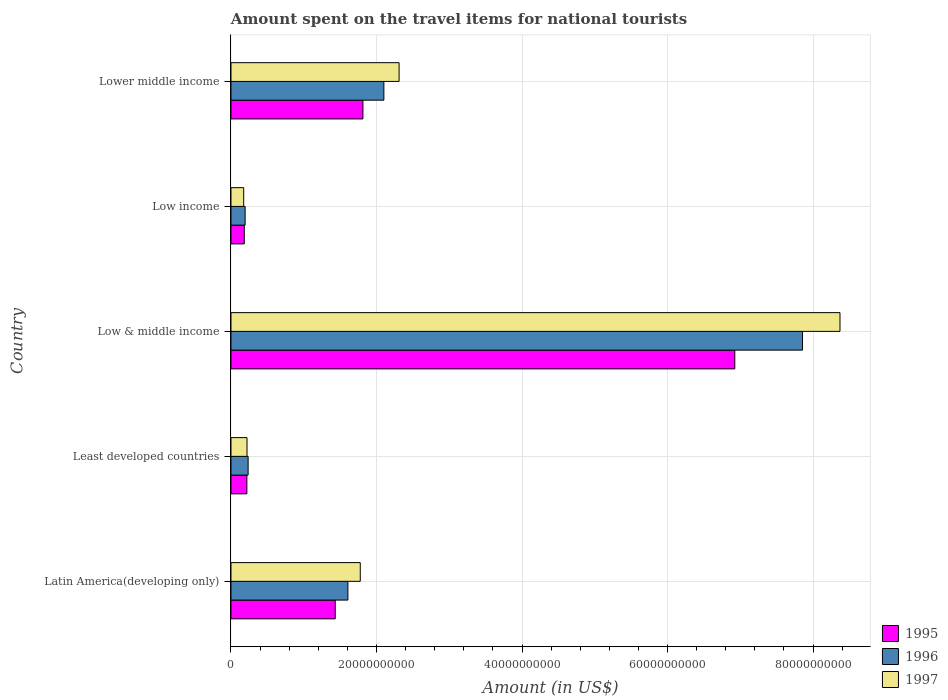How many groups of bars are there?
Your answer should be very brief. 5. Are the number of bars per tick equal to the number of legend labels?
Make the answer very short. Yes. How many bars are there on the 5th tick from the top?
Your response must be concise. 3. What is the amount spent on the travel items for national tourists in 1996 in Least developed countries?
Offer a very short reply. 2.36e+09. Across all countries, what is the maximum amount spent on the travel items for national tourists in 1996?
Your answer should be compact. 7.85e+1. Across all countries, what is the minimum amount spent on the travel items for national tourists in 1996?
Your answer should be very brief. 1.94e+09. In which country was the amount spent on the travel items for national tourists in 1997 maximum?
Your response must be concise. Low & middle income. In which country was the amount spent on the travel items for national tourists in 1995 minimum?
Make the answer very short. Low income. What is the total amount spent on the travel items for national tourists in 1995 in the graph?
Give a very brief answer. 1.06e+11. What is the difference between the amount spent on the travel items for national tourists in 1996 in Least developed countries and that in Low income?
Make the answer very short. 4.11e+08. What is the difference between the amount spent on the travel items for national tourists in 1995 in Lower middle income and the amount spent on the travel items for national tourists in 1996 in Low income?
Provide a succinct answer. 1.62e+1. What is the average amount spent on the travel items for national tourists in 1997 per country?
Provide a succinct answer. 2.57e+1. What is the difference between the amount spent on the travel items for national tourists in 1996 and amount spent on the travel items for national tourists in 1995 in Lower middle income?
Offer a terse response. 2.88e+09. In how many countries, is the amount spent on the travel items for national tourists in 1996 greater than 4000000000 US$?
Offer a very short reply. 3. What is the ratio of the amount spent on the travel items for national tourists in 1997 in Low income to that in Lower middle income?
Your response must be concise. 0.08. What is the difference between the highest and the second highest amount spent on the travel items for national tourists in 1997?
Give a very brief answer. 6.06e+1. What is the difference between the highest and the lowest amount spent on the travel items for national tourists in 1997?
Offer a very short reply. 8.19e+1. In how many countries, is the amount spent on the travel items for national tourists in 1997 greater than the average amount spent on the travel items for national tourists in 1997 taken over all countries?
Make the answer very short. 1. Is the sum of the amount spent on the travel items for national tourists in 1995 in Low income and Lower middle income greater than the maximum amount spent on the travel items for national tourists in 1996 across all countries?
Your answer should be very brief. No. Is it the case that in every country, the sum of the amount spent on the travel items for national tourists in 1997 and amount spent on the travel items for national tourists in 1995 is greater than the amount spent on the travel items for national tourists in 1996?
Offer a terse response. Yes. How many bars are there?
Your answer should be compact. 15. Are all the bars in the graph horizontal?
Provide a short and direct response. Yes. Are the values on the major ticks of X-axis written in scientific E-notation?
Offer a terse response. No. Does the graph contain any zero values?
Offer a very short reply. No. Where does the legend appear in the graph?
Your answer should be compact. Bottom right. How many legend labels are there?
Offer a very short reply. 3. What is the title of the graph?
Your answer should be very brief. Amount spent on the travel items for national tourists. What is the label or title of the X-axis?
Give a very brief answer. Amount (in US$). What is the label or title of the Y-axis?
Your answer should be very brief. Country. What is the Amount (in US$) of 1995 in Latin America(developing only)?
Your response must be concise. 1.43e+1. What is the Amount (in US$) of 1996 in Latin America(developing only)?
Give a very brief answer. 1.61e+1. What is the Amount (in US$) in 1997 in Latin America(developing only)?
Your answer should be very brief. 1.78e+1. What is the Amount (in US$) in 1995 in Least developed countries?
Offer a very short reply. 2.19e+09. What is the Amount (in US$) of 1996 in Least developed countries?
Keep it short and to the point. 2.36e+09. What is the Amount (in US$) in 1997 in Least developed countries?
Provide a succinct answer. 2.20e+09. What is the Amount (in US$) in 1995 in Low & middle income?
Your answer should be compact. 6.92e+1. What is the Amount (in US$) in 1996 in Low & middle income?
Offer a very short reply. 7.85e+1. What is the Amount (in US$) of 1997 in Low & middle income?
Offer a terse response. 8.37e+1. What is the Amount (in US$) of 1995 in Low income?
Offer a terse response. 1.83e+09. What is the Amount (in US$) in 1996 in Low income?
Your response must be concise. 1.94e+09. What is the Amount (in US$) of 1997 in Low income?
Provide a short and direct response. 1.75e+09. What is the Amount (in US$) in 1995 in Lower middle income?
Keep it short and to the point. 1.81e+1. What is the Amount (in US$) in 1996 in Lower middle income?
Provide a succinct answer. 2.10e+1. What is the Amount (in US$) of 1997 in Lower middle income?
Offer a terse response. 2.31e+1. Across all countries, what is the maximum Amount (in US$) of 1995?
Offer a terse response. 6.92e+1. Across all countries, what is the maximum Amount (in US$) of 1996?
Provide a succinct answer. 7.85e+1. Across all countries, what is the maximum Amount (in US$) in 1997?
Provide a succinct answer. 8.37e+1. Across all countries, what is the minimum Amount (in US$) of 1995?
Provide a short and direct response. 1.83e+09. Across all countries, what is the minimum Amount (in US$) of 1996?
Provide a succinct answer. 1.94e+09. Across all countries, what is the minimum Amount (in US$) of 1997?
Provide a succinct answer. 1.75e+09. What is the total Amount (in US$) in 1995 in the graph?
Your answer should be compact. 1.06e+11. What is the total Amount (in US$) of 1996 in the graph?
Offer a terse response. 1.20e+11. What is the total Amount (in US$) in 1997 in the graph?
Provide a short and direct response. 1.29e+11. What is the difference between the Amount (in US$) of 1995 in Latin America(developing only) and that in Least developed countries?
Give a very brief answer. 1.21e+1. What is the difference between the Amount (in US$) in 1996 in Latin America(developing only) and that in Least developed countries?
Offer a terse response. 1.37e+1. What is the difference between the Amount (in US$) of 1997 in Latin America(developing only) and that in Least developed countries?
Your response must be concise. 1.56e+1. What is the difference between the Amount (in US$) of 1995 in Latin America(developing only) and that in Low & middle income?
Your response must be concise. -5.49e+1. What is the difference between the Amount (in US$) of 1996 in Latin America(developing only) and that in Low & middle income?
Provide a succinct answer. -6.25e+1. What is the difference between the Amount (in US$) in 1997 in Latin America(developing only) and that in Low & middle income?
Provide a succinct answer. -6.59e+1. What is the difference between the Amount (in US$) in 1995 in Latin America(developing only) and that in Low income?
Provide a short and direct response. 1.25e+1. What is the difference between the Amount (in US$) of 1996 in Latin America(developing only) and that in Low income?
Provide a short and direct response. 1.41e+1. What is the difference between the Amount (in US$) of 1997 in Latin America(developing only) and that in Low income?
Provide a short and direct response. 1.60e+1. What is the difference between the Amount (in US$) in 1995 in Latin America(developing only) and that in Lower middle income?
Make the answer very short. -3.81e+09. What is the difference between the Amount (in US$) in 1996 in Latin America(developing only) and that in Lower middle income?
Keep it short and to the point. -4.95e+09. What is the difference between the Amount (in US$) in 1997 in Latin America(developing only) and that in Lower middle income?
Make the answer very short. -5.34e+09. What is the difference between the Amount (in US$) in 1995 in Least developed countries and that in Low & middle income?
Offer a terse response. -6.71e+1. What is the difference between the Amount (in US$) in 1996 in Least developed countries and that in Low & middle income?
Provide a short and direct response. -7.62e+1. What is the difference between the Amount (in US$) of 1997 in Least developed countries and that in Low & middle income?
Provide a short and direct response. -8.15e+1. What is the difference between the Amount (in US$) of 1995 in Least developed countries and that in Low income?
Provide a succinct answer. 3.56e+08. What is the difference between the Amount (in US$) in 1996 in Least developed countries and that in Low income?
Your answer should be compact. 4.11e+08. What is the difference between the Amount (in US$) of 1997 in Least developed countries and that in Low income?
Make the answer very short. 4.55e+08. What is the difference between the Amount (in US$) of 1995 in Least developed countries and that in Lower middle income?
Your answer should be compact. -1.59e+1. What is the difference between the Amount (in US$) of 1996 in Least developed countries and that in Lower middle income?
Offer a terse response. -1.87e+1. What is the difference between the Amount (in US$) of 1997 in Least developed countries and that in Lower middle income?
Your answer should be very brief. -2.09e+1. What is the difference between the Amount (in US$) in 1995 in Low & middle income and that in Low income?
Make the answer very short. 6.74e+1. What is the difference between the Amount (in US$) in 1996 in Low & middle income and that in Low income?
Offer a terse response. 7.66e+1. What is the difference between the Amount (in US$) in 1997 in Low & middle income and that in Low income?
Keep it short and to the point. 8.19e+1. What is the difference between the Amount (in US$) in 1995 in Low & middle income and that in Lower middle income?
Provide a succinct answer. 5.11e+1. What is the difference between the Amount (in US$) in 1996 in Low & middle income and that in Lower middle income?
Keep it short and to the point. 5.75e+1. What is the difference between the Amount (in US$) of 1997 in Low & middle income and that in Lower middle income?
Give a very brief answer. 6.06e+1. What is the difference between the Amount (in US$) of 1995 in Low income and that in Lower middle income?
Ensure brevity in your answer.  -1.63e+1. What is the difference between the Amount (in US$) of 1996 in Low income and that in Lower middle income?
Offer a very short reply. -1.91e+1. What is the difference between the Amount (in US$) in 1997 in Low income and that in Lower middle income?
Make the answer very short. -2.14e+1. What is the difference between the Amount (in US$) of 1995 in Latin America(developing only) and the Amount (in US$) of 1996 in Least developed countries?
Offer a terse response. 1.20e+1. What is the difference between the Amount (in US$) of 1995 in Latin America(developing only) and the Amount (in US$) of 1997 in Least developed countries?
Make the answer very short. 1.21e+1. What is the difference between the Amount (in US$) of 1996 in Latin America(developing only) and the Amount (in US$) of 1997 in Least developed countries?
Offer a terse response. 1.39e+1. What is the difference between the Amount (in US$) of 1995 in Latin America(developing only) and the Amount (in US$) of 1996 in Low & middle income?
Provide a short and direct response. -6.42e+1. What is the difference between the Amount (in US$) of 1995 in Latin America(developing only) and the Amount (in US$) of 1997 in Low & middle income?
Ensure brevity in your answer.  -6.94e+1. What is the difference between the Amount (in US$) of 1996 in Latin America(developing only) and the Amount (in US$) of 1997 in Low & middle income?
Offer a very short reply. -6.76e+1. What is the difference between the Amount (in US$) in 1995 in Latin America(developing only) and the Amount (in US$) in 1996 in Low income?
Offer a terse response. 1.24e+1. What is the difference between the Amount (in US$) in 1995 in Latin America(developing only) and the Amount (in US$) in 1997 in Low income?
Make the answer very short. 1.26e+1. What is the difference between the Amount (in US$) of 1996 in Latin America(developing only) and the Amount (in US$) of 1997 in Low income?
Provide a succinct answer. 1.43e+1. What is the difference between the Amount (in US$) of 1995 in Latin America(developing only) and the Amount (in US$) of 1996 in Lower middle income?
Your response must be concise. -6.69e+09. What is the difference between the Amount (in US$) in 1995 in Latin America(developing only) and the Amount (in US$) in 1997 in Lower middle income?
Your answer should be very brief. -8.78e+09. What is the difference between the Amount (in US$) in 1996 in Latin America(developing only) and the Amount (in US$) in 1997 in Lower middle income?
Keep it short and to the point. -7.04e+09. What is the difference between the Amount (in US$) of 1995 in Least developed countries and the Amount (in US$) of 1996 in Low & middle income?
Give a very brief answer. -7.64e+1. What is the difference between the Amount (in US$) of 1995 in Least developed countries and the Amount (in US$) of 1997 in Low & middle income?
Offer a very short reply. -8.15e+1. What is the difference between the Amount (in US$) in 1996 in Least developed countries and the Amount (in US$) in 1997 in Low & middle income?
Give a very brief answer. -8.13e+1. What is the difference between the Amount (in US$) of 1995 in Least developed countries and the Amount (in US$) of 1996 in Low income?
Give a very brief answer. 2.41e+08. What is the difference between the Amount (in US$) in 1995 in Least developed countries and the Amount (in US$) in 1997 in Low income?
Offer a very short reply. 4.37e+08. What is the difference between the Amount (in US$) in 1996 in Least developed countries and the Amount (in US$) in 1997 in Low income?
Offer a terse response. 6.07e+08. What is the difference between the Amount (in US$) in 1995 in Least developed countries and the Amount (in US$) in 1996 in Lower middle income?
Your answer should be very brief. -1.88e+1. What is the difference between the Amount (in US$) of 1995 in Least developed countries and the Amount (in US$) of 1997 in Lower middle income?
Ensure brevity in your answer.  -2.09e+1. What is the difference between the Amount (in US$) in 1996 in Least developed countries and the Amount (in US$) in 1997 in Lower middle income?
Give a very brief answer. -2.07e+1. What is the difference between the Amount (in US$) of 1995 in Low & middle income and the Amount (in US$) of 1996 in Low income?
Make the answer very short. 6.73e+1. What is the difference between the Amount (in US$) in 1995 in Low & middle income and the Amount (in US$) in 1997 in Low income?
Your answer should be very brief. 6.75e+1. What is the difference between the Amount (in US$) in 1996 in Low & middle income and the Amount (in US$) in 1997 in Low income?
Your answer should be very brief. 7.68e+1. What is the difference between the Amount (in US$) of 1995 in Low & middle income and the Amount (in US$) of 1996 in Lower middle income?
Provide a short and direct response. 4.82e+1. What is the difference between the Amount (in US$) in 1995 in Low & middle income and the Amount (in US$) in 1997 in Lower middle income?
Offer a terse response. 4.61e+1. What is the difference between the Amount (in US$) in 1996 in Low & middle income and the Amount (in US$) in 1997 in Lower middle income?
Give a very brief answer. 5.54e+1. What is the difference between the Amount (in US$) of 1995 in Low income and the Amount (in US$) of 1996 in Lower middle income?
Make the answer very short. -1.92e+1. What is the difference between the Amount (in US$) of 1995 in Low income and the Amount (in US$) of 1997 in Lower middle income?
Make the answer very short. -2.13e+1. What is the difference between the Amount (in US$) of 1996 in Low income and the Amount (in US$) of 1997 in Lower middle income?
Offer a terse response. -2.12e+1. What is the average Amount (in US$) in 1995 per country?
Ensure brevity in your answer.  2.11e+1. What is the average Amount (in US$) in 1996 per country?
Offer a very short reply. 2.40e+1. What is the average Amount (in US$) of 1997 per country?
Your answer should be compact. 2.57e+1. What is the difference between the Amount (in US$) in 1995 and Amount (in US$) in 1996 in Latin America(developing only)?
Your answer should be compact. -1.74e+09. What is the difference between the Amount (in US$) of 1995 and Amount (in US$) of 1997 in Latin America(developing only)?
Offer a terse response. -3.44e+09. What is the difference between the Amount (in US$) in 1996 and Amount (in US$) in 1997 in Latin America(developing only)?
Offer a very short reply. -1.70e+09. What is the difference between the Amount (in US$) in 1995 and Amount (in US$) in 1996 in Least developed countries?
Give a very brief answer. -1.70e+08. What is the difference between the Amount (in US$) of 1995 and Amount (in US$) of 1997 in Least developed countries?
Offer a very short reply. -1.81e+07. What is the difference between the Amount (in US$) in 1996 and Amount (in US$) in 1997 in Least developed countries?
Your answer should be very brief. 1.52e+08. What is the difference between the Amount (in US$) in 1995 and Amount (in US$) in 1996 in Low & middle income?
Offer a terse response. -9.31e+09. What is the difference between the Amount (in US$) in 1995 and Amount (in US$) in 1997 in Low & middle income?
Offer a terse response. -1.45e+1. What is the difference between the Amount (in US$) in 1996 and Amount (in US$) in 1997 in Low & middle income?
Provide a short and direct response. -5.15e+09. What is the difference between the Amount (in US$) in 1995 and Amount (in US$) in 1996 in Low income?
Offer a very short reply. -1.15e+08. What is the difference between the Amount (in US$) of 1995 and Amount (in US$) of 1997 in Low income?
Keep it short and to the point. 8.10e+07. What is the difference between the Amount (in US$) of 1996 and Amount (in US$) of 1997 in Low income?
Make the answer very short. 1.96e+08. What is the difference between the Amount (in US$) of 1995 and Amount (in US$) of 1996 in Lower middle income?
Offer a terse response. -2.88e+09. What is the difference between the Amount (in US$) in 1995 and Amount (in US$) in 1997 in Lower middle income?
Your answer should be very brief. -4.97e+09. What is the difference between the Amount (in US$) in 1996 and Amount (in US$) in 1997 in Lower middle income?
Ensure brevity in your answer.  -2.09e+09. What is the ratio of the Amount (in US$) of 1995 in Latin America(developing only) to that in Least developed countries?
Your response must be concise. 6.56. What is the ratio of the Amount (in US$) of 1996 in Latin America(developing only) to that in Least developed countries?
Provide a short and direct response. 6.82. What is the ratio of the Amount (in US$) of 1997 in Latin America(developing only) to that in Least developed countries?
Your answer should be very brief. 8.06. What is the ratio of the Amount (in US$) of 1995 in Latin America(developing only) to that in Low & middle income?
Give a very brief answer. 0.21. What is the ratio of the Amount (in US$) of 1996 in Latin America(developing only) to that in Low & middle income?
Your response must be concise. 0.2. What is the ratio of the Amount (in US$) in 1997 in Latin America(developing only) to that in Low & middle income?
Make the answer very short. 0.21. What is the ratio of the Amount (in US$) of 1995 in Latin America(developing only) to that in Low income?
Provide a succinct answer. 7.83. What is the ratio of the Amount (in US$) of 1996 in Latin America(developing only) to that in Low income?
Your response must be concise. 8.26. What is the ratio of the Amount (in US$) in 1997 in Latin America(developing only) to that in Low income?
Your response must be concise. 10.16. What is the ratio of the Amount (in US$) in 1995 in Latin America(developing only) to that in Lower middle income?
Your response must be concise. 0.79. What is the ratio of the Amount (in US$) in 1996 in Latin America(developing only) to that in Lower middle income?
Offer a terse response. 0.76. What is the ratio of the Amount (in US$) in 1997 in Latin America(developing only) to that in Lower middle income?
Your answer should be very brief. 0.77. What is the ratio of the Amount (in US$) of 1995 in Least developed countries to that in Low & middle income?
Provide a short and direct response. 0.03. What is the ratio of the Amount (in US$) in 1996 in Least developed countries to that in Low & middle income?
Offer a terse response. 0.03. What is the ratio of the Amount (in US$) in 1997 in Least developed countries to that in Low & middle income?
Make the answer very short. 0.03. What is the ratio of the Amount (in US$) in 1995 in Least developed countries to that in Low income?
Your answer should be very brief. 1.19. What is the ratio of the Amount (in US$) in 1996 in Least developed countries to that in Low income?
Your answer should be very brief. 1.21. What is the ratio of the Amount (in US$) of 1997 in Least developed countries to that in Low income?
Offer a terse response. 1.26. What is the ratio of the Amount (in US$) of 1995 in Least developed countries to that in Lower middle income?
Provide a succinct answer. 0.12. What is the ratio of the Amount (in US$) in 1996 in Least developed countries to that in Lower middle income?
Offer a terse response. 0.11. What is the ratio of the Amount (in US$) of 1997 in Least developed countries to that in Lower middle income?
Your answer should be very brief. 0.1. What is the ratio of the Amount (in US$) in 1995 in Low & middle income to that in Low income?
Provide a short and direct response. 37.85. What is the ratio of the Amount (in US$) of 1996 in Low & middle income to that in Low income?
Your answer should be compact. 40.39. What is the ratio of the Amount (in US$) in 1997 in Low & middle income to that in Low income?
Give a very brief answer. 47.87. What is the ratio of the Amount (in US$) of 1995 in Low & middle income to that in Lower middle income?
Your response must be concise. 3.82. What is the ratio of the Amount (in US$) in 1996 in Low & middle income to that in Lower middle income?
Your response must be concise. 3.74. What is the ratio of the Amount (in US$) in 1997 in Low & middle income to that in Lower middle income?
Your response must be concise. 3.62. What is the ratio of the Amount (in US$) in 1995 in Low income to that in Lower middle income?
Your answer should be very brief. 0.1. What is the ratio of the Amount (in US$) in 1996 in Low income to that in Lower middle income?
Ensure brevity in your answer.  0.09. What is the ratio of the Amount (in US$) of 1997 in Low income to that in Lower middle income?
Give a very brief answer. 0.08. What is the difference between the highest and the second highest Amount (in US$) in 1995?
Provide a short and direct response. 5.11e+1. What is the difference between the highest and the second highest Amount (in US$) of 1996?
Offer a very short reply. 5.75e+1. What is the difference between the highest and the second highest Amount (in US$) in 1997?
Provide a short and direct response. 6.06e+1. What is the difference between the highest and the lowest Amount (in US$) of 1995?
Keep it short and to the point. 6.74e+1. What is the difference between the highest and the lowest Amount (in US$) of 1996?
Make the answer very short. 7.66e+1. What is the difference between the highest and the lowest Amount (in US$) in 1997?
Provide a succinct answer. 8.19e+1. 